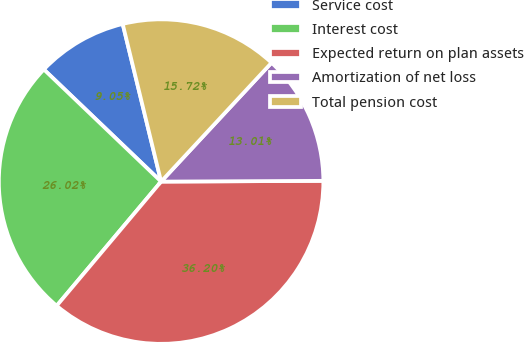Convert chart. <chart><loc_0><loc_0><loc_500><loc_500><pie_chart><fcel>Service cost<fcel>Interest cost<fcel>Expected return on plan assets<fcel>Amortization of net loss<fcel>Total pension cost<nl><fcel>9.05%<fcel>26.02%<fcel>36.2%<fcel>13.01%<fcel>15.72%<nl></chart> 